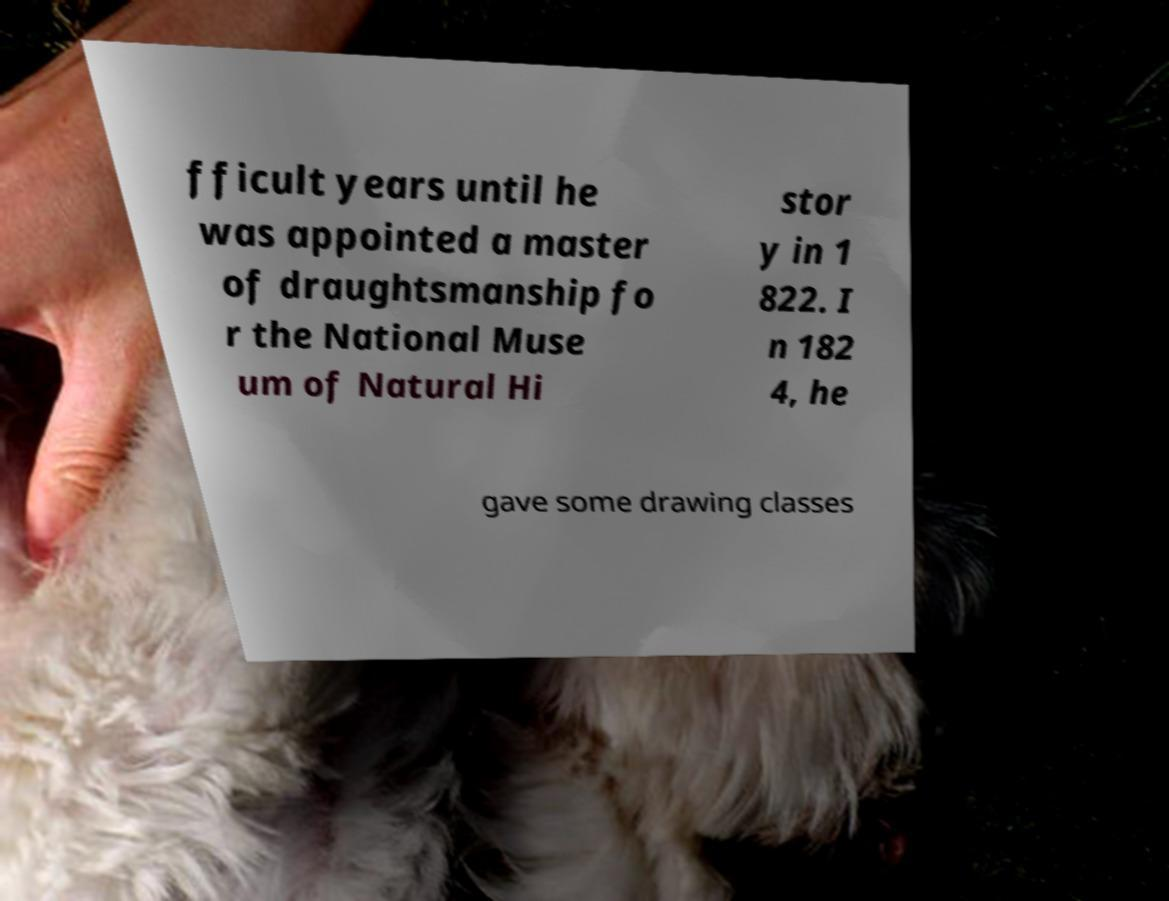Please read and relay the text visible in this image. What does it say? fficult years until he was appointed a master of draughtsmanship fo r the National Muse um of Natural Hi stor y in 1 822. I n 182 4, he gave some drawing classes 